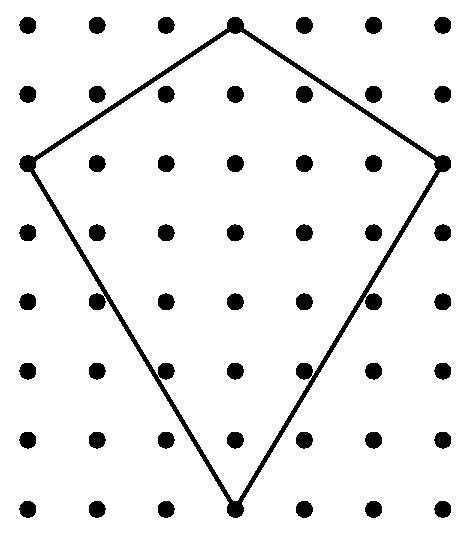Genevieve puts bracing on her large kite in the form of a cross connecting opposite corners of the kite. How many inches of bracing material does she need? To determine the total inches of bracing material Genevieve needs, we need to calculate the diagonals of the kite, assuming it's a symmetric shape. If each diagonal is, for instance, 19.5 inches, then combined she would need 39 inches for both. However, without knowing the exact measurements, we can't provide a precise answer. Therefore, it's crucial to measure the length of one diagonal and then double it to find the total amount of bracing material required. 